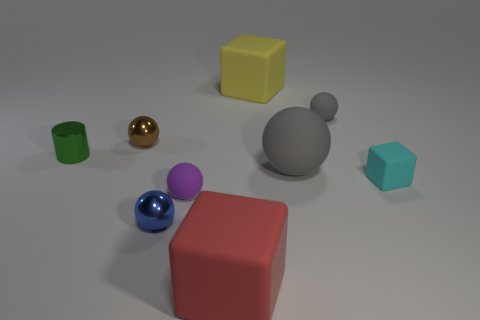What shape is the large red object?
Keep it short and to the point. Cube. What is the size of the other ball that is the same color as the big sphere?
Your answer should be very brief. Small. How big is the matte block that is on the left side of the big block that is on the right side of the red matte cube?
Your answer should be very brief. Large. There is a matte cube right of the big sphere; how big is it?
Your answer should be very brief. Small. Is the number of red rubber blocks on the right side of the small block less than the number of metallic objects that are in front of the purple thing?
Keep it short and to the point. Yes. The tiny matte cube has what color?
Make the answer very short. Cyan. Are there any spheres of the same color as the tiny cylinder?
Provide a short and direct response. No. There is a large matte thing that is to the left of the matte block behind the cyan matte block on the right side of the green shiny object; what is its shape?
Provide a short and direct response. Cube. What is the material of the small ball to the right of the red thing?
Your answer should be compact. Rubber. There is a block left of the matte cube behind the small thing that is to the right of the tiny gray matte thing; how big is it?
Ensure brevity in your answer.  Large. 